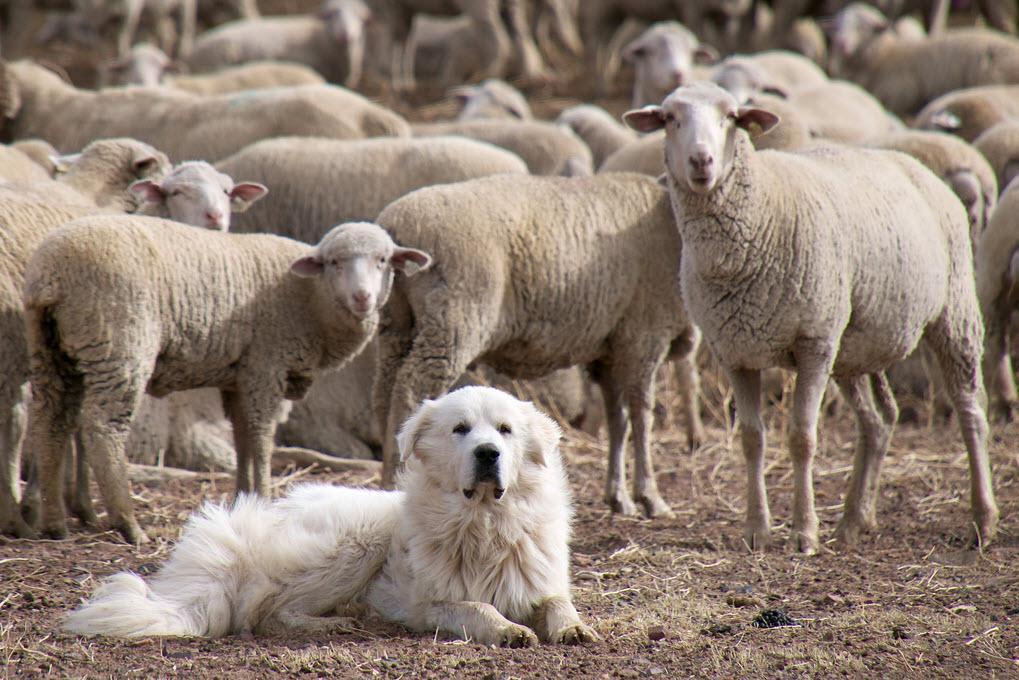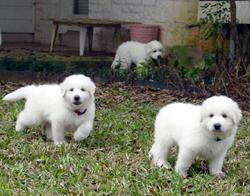The first image is the image on the left, the second image is the image on the right. Assess this claim about the two images: "There are more animals in the image on the right.". Correct or not? Answer yes or no. No. The first image is the image on the left, the second image is the image on the right. Assess this claim about the two images: "A white furry dog is in front of a group of sheep.". Correct or not? Answer yes or no. Yes. 